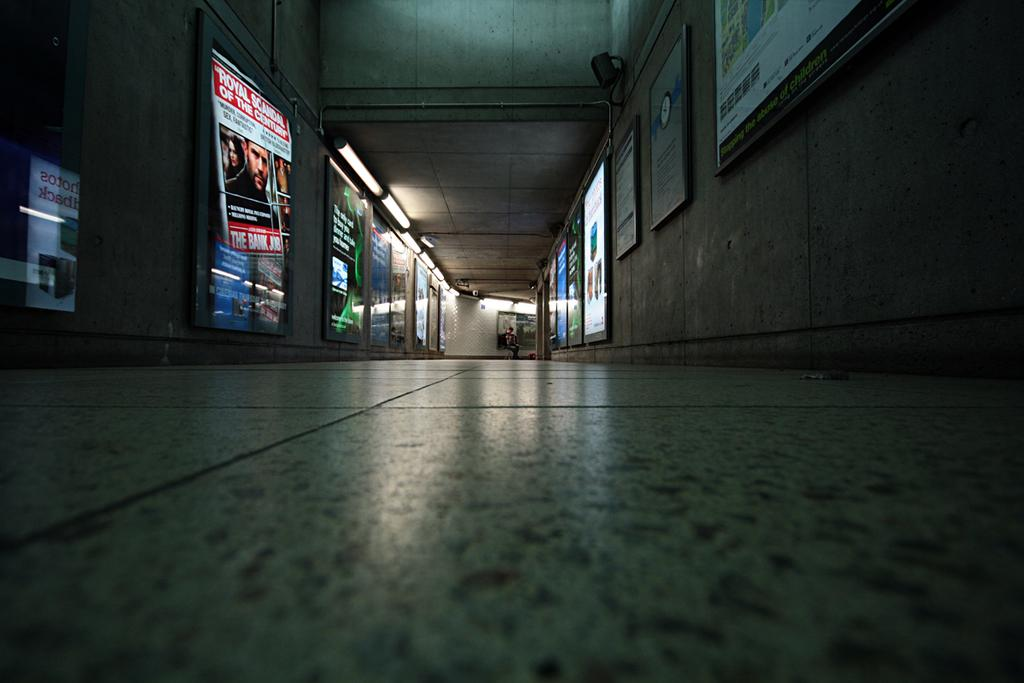What type of structure is visible in the image? There is a building in the image. What can be seen on the wall of the building? There are many boards and lights on the wall. How many kittens are sitting on the lamp in the image? There is no lamp or kittens present in the image. 